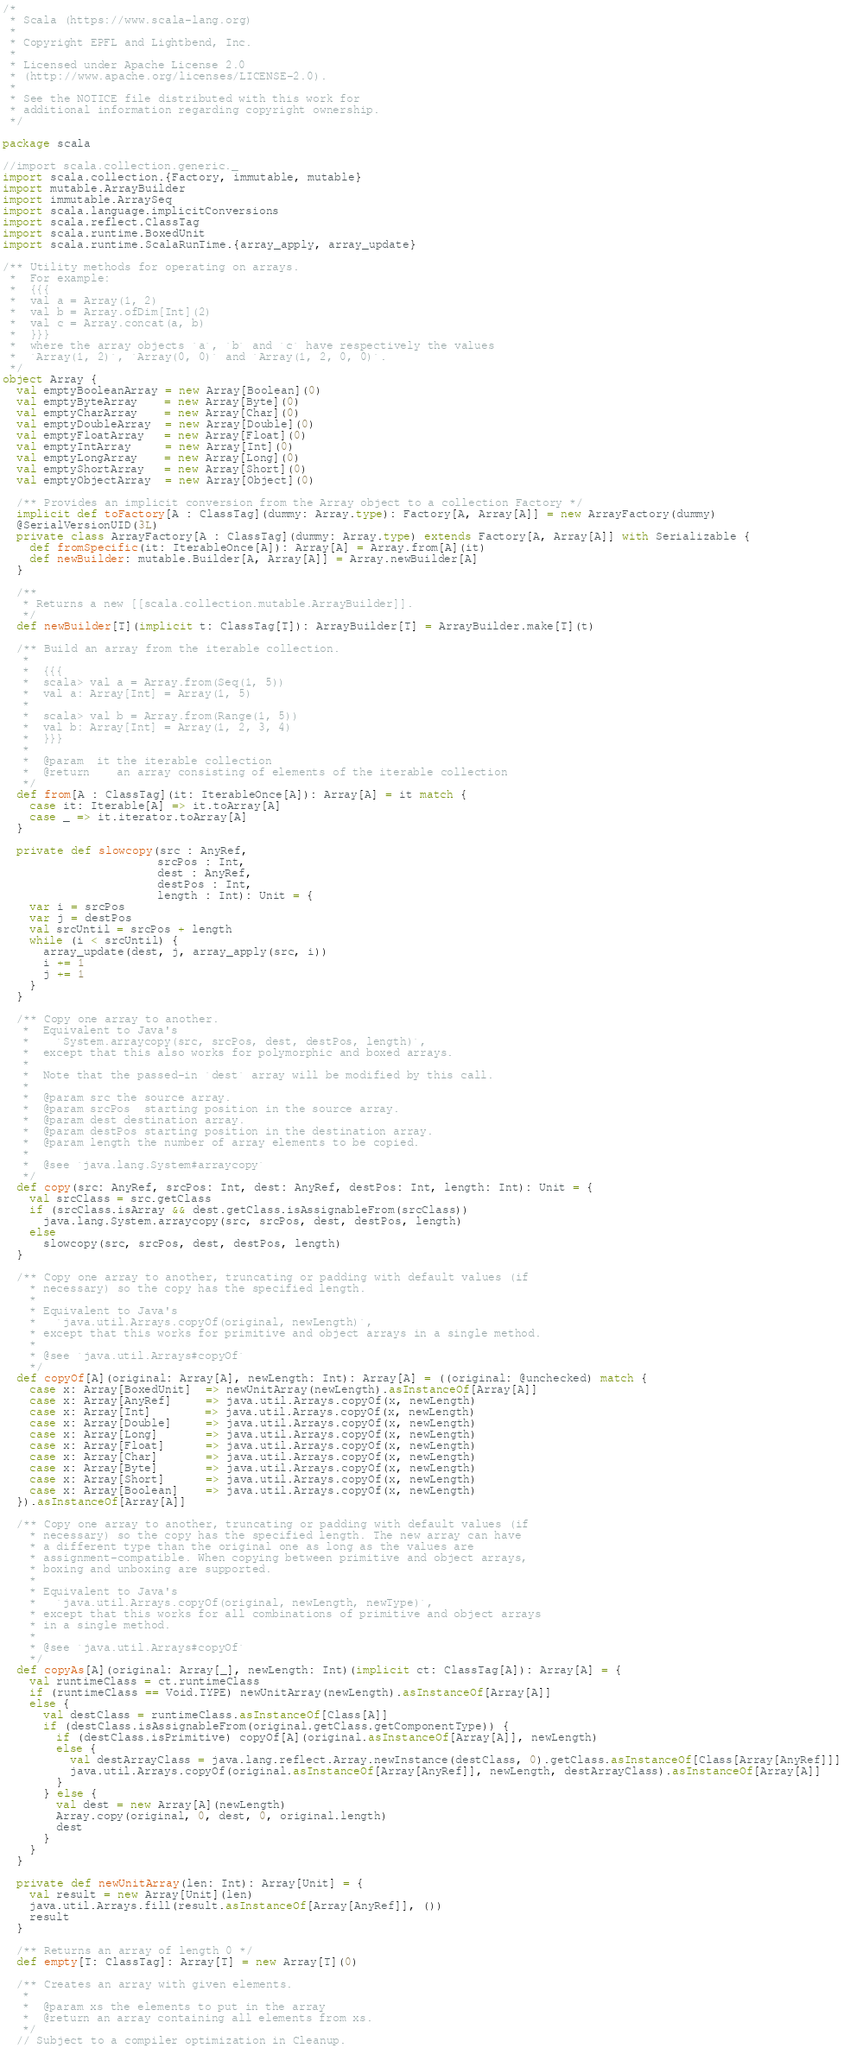<code> <loc_0><loc_0><loc_500><loc_500><_Scala_>/*
 * Scala (https://www.scala-lang.org)
 *
 * Copyright EPFL and Lightbend, Inc.
 *
 * Licensed under Apache License 2.0
 * (http://www.apache.org/licenses/LICENSE-2.0).
 *
 * See the NOTICE file distributed with this work for
 * additional information regarding copyright ownership.
 */

package scala

//import scala.collection.generic._
import scala.collection.{Factory, immutable, mutable}
import mutable.ArrayBuilder
import immutable.ArraySeq
import scala.language.implicitConversions
import scala.reflect.ClassTag
import scala.runtime.BoxedUnit
import scala.runtime.ScalaRunTime.{array_apply, array_update}

/** Utility methods for operating on arrays.
 *  For example:
 *  {{{
 *  val a = Array(1, 2)
 *  val b = Array.ofDim[Int](2)
 *  val c = Array.concat(a, b)
 *  }}}
 *  where the array objects `a`, `b` and `c` have respectively the values
 *  `Array(1, 2)`, `Array(0, 0)` and `Array(1, 2, 0, 0)`.
 */
object Array {
  val emptyBooleanArray = new Array[Boolean](0)
  val emptyByteArray    = new Array[Byte](0)
  val emptyCharArray    = new Array[Char](0)
  val emptyDoubleArray  = new Array[Double](0)
  val emptyFloatArray   = new Array[Float](0)
  val emptyIntArray     = new Array[Int](0)
  val emptyLongArray    = new Array[Long](0)
  val emptyShortArray   = new Array[Short](0)
  val emptyObjectArray  = new Array[Object](0)

  /** Provides an implicit conversion from the Array object to a collection Factory */
  implicit def toFactory[A : ClassTag](dummy: Array.type): Factory[A, Array[A]] = new ArrayFactory(dummy)
  @SerialVersionUID(3L)
  private class ArrayFactory[A : ClassTag](dummy: Array.type) extends Factory[A, Array[A]] with Serializable {
    def fromSpecific(it: IterableOnce[A]): Array[A] = Array.from[A](it)
    def newBuilder: mutable.Builder[A, Array[A]] = Array.newBuilder[A]
  }

  /**
   * Returns a new [[scala.collection.mutable.ArrayBuilder]].
   */
  def newBuilder[T](implicit t: ClassTag[T]): ArrayBuilder[T] = ArrayBuilder.make[T](t)

  /** Build an array from the iterable collection.
   *
   *  {{{
   *  scala> val a = Array.from(Seq(1, 5))
   *  val a: Array[Int] = Array(1, 5)
   *
   *  scala> val b = Array.from(Range(1, 5))
   *  val b: Array[Int] = Array(1, 2, 3, 4)
   *  }}}
   *
   *  @param  it the iterable collection
   *  @return    an array consisting of elements of the iterable collection
   */
  def from[A : ClassTag](it: IterableOnce[A]): Array[A] = it match {
    case it: Iterable[A] => it.toArray[A]
    case _ => it.iterator.toArray[A]
  }

  private def slowcopy(src : AnyRef,
                       srcPos : Int,
                       dest : AnyRef,
                       destPos : Int,
                       length : Int): Unit = {
    var i = srcPos
    var j = destPos
    val srcUntil = srcPos + length
    while (i < srcUntil) {
      array_update(dest, j, array_apply(src, i))
      i += 1
      j += 1
    }
  }

  /** Copy one array to another.
   *  Equivalent to Java's
   *    `System.arraycopy(src, srcPos, dest, destPos, length)`,
   *  except that this also works for polymorphic and boxed arrays.
   *
   *  Note that the passed-in `dest` array will be modified by this call.
   *
   *  @param src the source array.
   *  @param srcPos  starting position in the source array.
   *  @param dest destination array.
   *  @param destPos starting position in the destination array.
   *  @param length the number of array elements to be copied.
   *
   *  @see `java.lang.System#arraycopy`
   */
  def copy(src: AnyRef, srcPos: Int, dest: AnyRef, destPos: Int, length: Int): Unit = {
    val srcClass = src.getClass
    if (srcClass.isArray && dest.getClass.isAssignableFrom(srcClass))
      java.lang.System.arraycopy(src, srcPos, dest, destPos, length)
    else
      slowcopy(src, srcPos, dest, destPos, length)
  }

  /** Copy one array to another, truncating or padding with default values (if
    * necessary) so the copy has the specified length.
    *
    * Equivalent to Java's
    *   `java.util.Arrays.copyOf(original, newLength)`,
    * except that this works for primitive and object arrays in a single method.
    *
    * @see `java.util.Arrays#copyOf`
    */
  def copyOf[A](original: Array[A], newLength: Int): Array[A] = ((original: @unchecked) match {
    case x: Array[BoxedUnit]  => newUnitArray(newLength).asInstanceOf[Array[A]]
    case x: Array[AnyRef]     => java.util.Arrays.copyOf(x, newLength)
    case x: Array[Int]        => java.util.Arrays.copyOf(x, newLength)
    case x: Array[Double]     => java.util.Arrays.copyOf(x, newLength)
    case x: Array[Long]       => java.util.Arrays.copyOf(x, newLength)
    case x: Array[Float]      => java.util.Arrays.copyOf(x, newLength)
    case x: Array[Char]       => java.util.Arrays.copyOf(x, newLength)
    case x: Array[Byte]       => java.util.Arrays.copyOf(x, newLength)
    case x: Array[Short]      => java.util.Arrays.copyOf(x, newLength)
    case x: Array[Boolean]    => java.util.Arrays.copyOf(x, newLength)
  }).asInstanceOf[Array[A]]

  /** Copy one array to another, truncating or padding with default values (if
    * necessary) so the copy has the specified length. The new array can have
    * a different type than the original one as long as the values are
    * assignment-compatible. When copying between primitive and object arrays,
    * boxing and unboxing are supported.
    *
    * Equivalent to Java's
    *   `java.util.Arrays.copyOf(original, newLength, newType)`,
    * except that this works for all combinations of primitive and object arrays
    * in a single method.
    *
    * @see `java.util.Arrays#copyOf`
    */
  def copyAs[A](original: Array[_], newLength: Int)(implicit ct: ClassTag[A]): Array[A] = {
    val runtimeClass = ct.runtimeClass
    if (runtimeClass == Void.TYPE) newUnitArray(newLength).asInstanceOf[Array[A]]
    else {
      val destClass = runtimeClass.asInstanceOf[Class[A]]
      if (destClass.isAssignableFrom(original.getClass.getComponentType)) {
        if (destClass.isPrimitive) copyOf[A](original.asInstanceOf[Array[A]], newLength)
        else {
          val destArrayClass = java.lang.reflect.Array.newInstance(destClass, 0).getClass.asInstanceOf[Class[Array[AnyRef]]]
          java.util.Arrays.copyOf(original.asInstanceOf[Array[AnyRef]], newLength, destArrayClass).asInstanceOf[Array[A]]
        }
      } else {
        val dest = new Array[A](newLength)
        Array.copy(original, 0, dest, 0, original.length)
        dest
      }
    }
  }

  private def newUnitArray(len: Int): Array[Unit] = {
    val result = new Array[Unit](len)
    java.util.Arrays.fill(result.asInstanceOf[Array[AnyRef]], ())
    result
  }

  /** Returns an array of length 0 */
  def empty[T: ClassTag]: Array[T] = new Array[T](0)

  /** Creates an array with given elements.
   *
   *  @param xs the elements to put in the array
   *  @return an array containing all elements from xs.
   */
  // Subject to a compiler optimization in Cleanup.</code> 